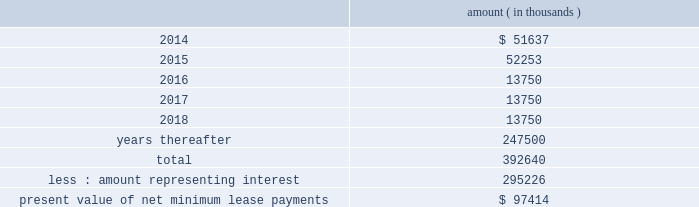Entergy corporation and subsidiaries notes to financial statements this difference as a regulatory asset or liability on an ongoing basis , resulting in a zero net balance for the regulatory asset at the end of the lease term .
The amount was a net regulatory liability of $ 61.6 million and $ 27.8 million as of december 31 , 2013 and 2012 , respectively .
As of december 31 , 2013 , system energy had future minimum lease payments ( reflecting an implicit rate of 5.13% ( 5.13 % ) ) , which are recorded as long-term debt , as follows : amount ( in thousands ) .

What are the future minimum lease payments in 2014 as a percentage of the total future minimum lease payments? 
Computations: (51637 / 392640)
Answer: 0.13151. 